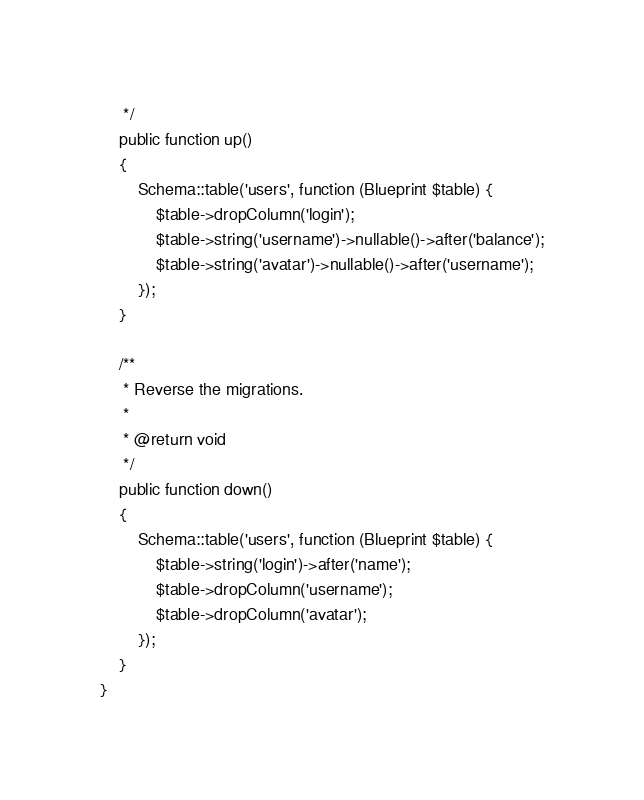Convert code to text. <code><loc_0><loc_0><loc_500><loc_500><_PHP_>     */
    public function up()
    {
        Schema::table('users', function (Blueprint $table) {
            $table->dropColumn('login');
            $table->string('username')->nullable()->after('balance');
            $table->string('avatar')->nullable()->after('username');
        });
    }

    /**
     * Reverse the migrations.
     *
     * @return void
     */
    public function down()
    {
        Schema::table('users', function (Blueprint $table) {
            $table->string('login')->after('name');
            $table->dropColumn('username');
            $table->dropColumn('avatar');
        });
    }
}
</code> 